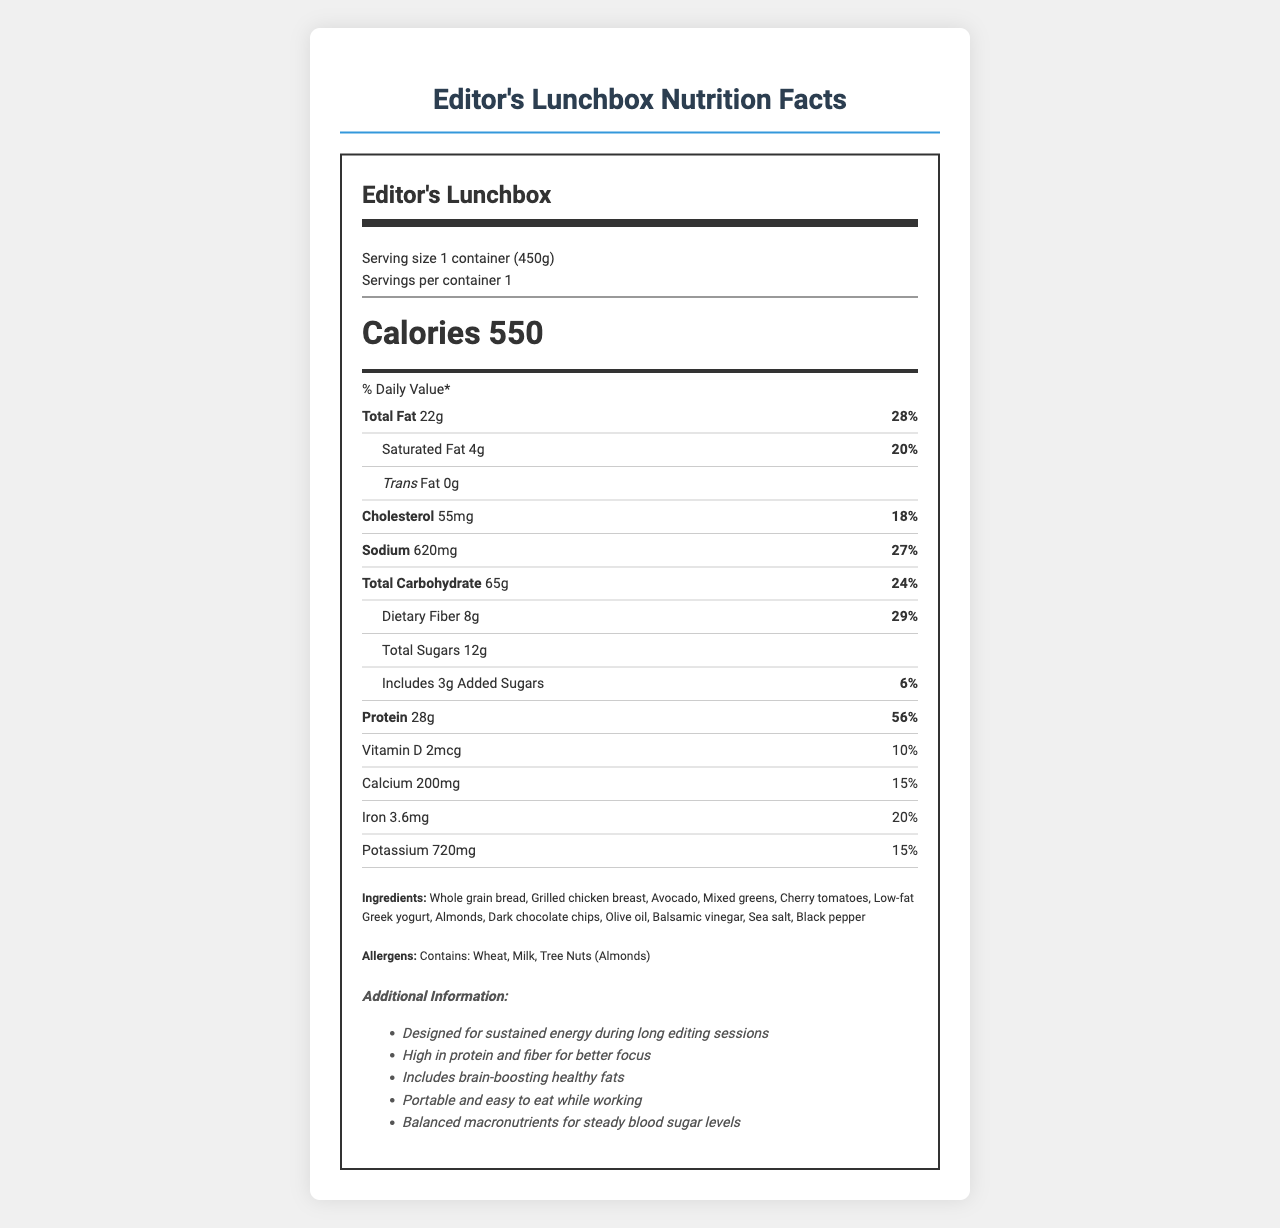what is the serving size of the Editor's Lunchbox? The serving size is mentioned at the beginning of the document under the serving info section: “Serving size 1 container (450g).”
Answer: 1 container (450g) how much protein is in the Editor's Lunchbox? The protein amount is listed in the nutrient section as “Protein 28g”.
Answer: 28g what are the three allergens listed in the Editor's Lunchbox? The allergens are clearly stated under the allergens section: “Contains: Wheat, Milk, Tree Nuts (Almonds).”
Answer: Wheat, Milk, Tree Nuts (Almonds) what is the total carbohydrate content? The total carbohydrate content is listed under the nutrient section as “Total Carbohydrate 65g”.
Answer: 65g how many calories does one serving of the Editor's Lunchbox contain? The calorie count is prominently displayed in a large font in the document: “Calories 550”.
Answer: 550 what is the daily value percentage of saturated fat? The daily value for saturated fat is listed as “Saturated Fat 4g 20%”.
Answer: 20% is the sodium content under 500mg? The sodium content is 620mg, which is above 500mg.
Answer: No describe the main idea of the document This document offers a comprehensive overview of the Editor's Lunchbox, focusing on its nutritional content and suitability for film editors engaged in lengthy work sessions.
Answer: The document provides detailed nutrition information about the Editor’s Lunchbox, a balanced meal designed for on-set editing work. It includes calorie count, macronutrient breakdown, and daily value percentages for various nutrients. Additionally, the ingredients, allergens, and some additional information to highlight its benefits for long editing sessions are provided. what is the highest percentage daily value nutrient in the Editor's Lunchbox? A. Sodium B. Protein C. Dietary Fiber D. Iron The protein daily value percentage is the highest at 56%.
Answer: Protein which of the following is not an ingredient in the Editor's Lunchbox? I. Blueberries II. Whole grain bread III. Almonds Blueberries are not listed among the ingredients. The ingredients include Whole grain bread and Almonds.
Answer: I. Blueberries how much vitamin D does the Editor's Lunchbox contain? The amount of vitamin D is listed as 2mcg under the vitamin content section.
Answer: 2mcg does the Editor's Lunchbox contain any trans fat? The document lists the trans fat amount as 0g.
Answer: No what are some additional benefits mentioned for the Editor's Lunchbox? These benefits are listed at the end of the document under the additional information section in bullet points.
Answer: Designed for sustained energy during long editing sessions; High in protein and fiber for better focus; Includes brain-boosting healthy fats; Portable and easy to eat while working; Balanced macronutrients for steady blood sugar levels. how much potassium is in one serving of the Editor's Lunchbox? The document lists Potassium content as 720mg.
Answer: 720mg does the document provide information on the environmental impact of the Editor's Lunchbox? The document does not mention anything regarding the environmental impact of the Editor's Lunchbox.
Answer: Not enough information 